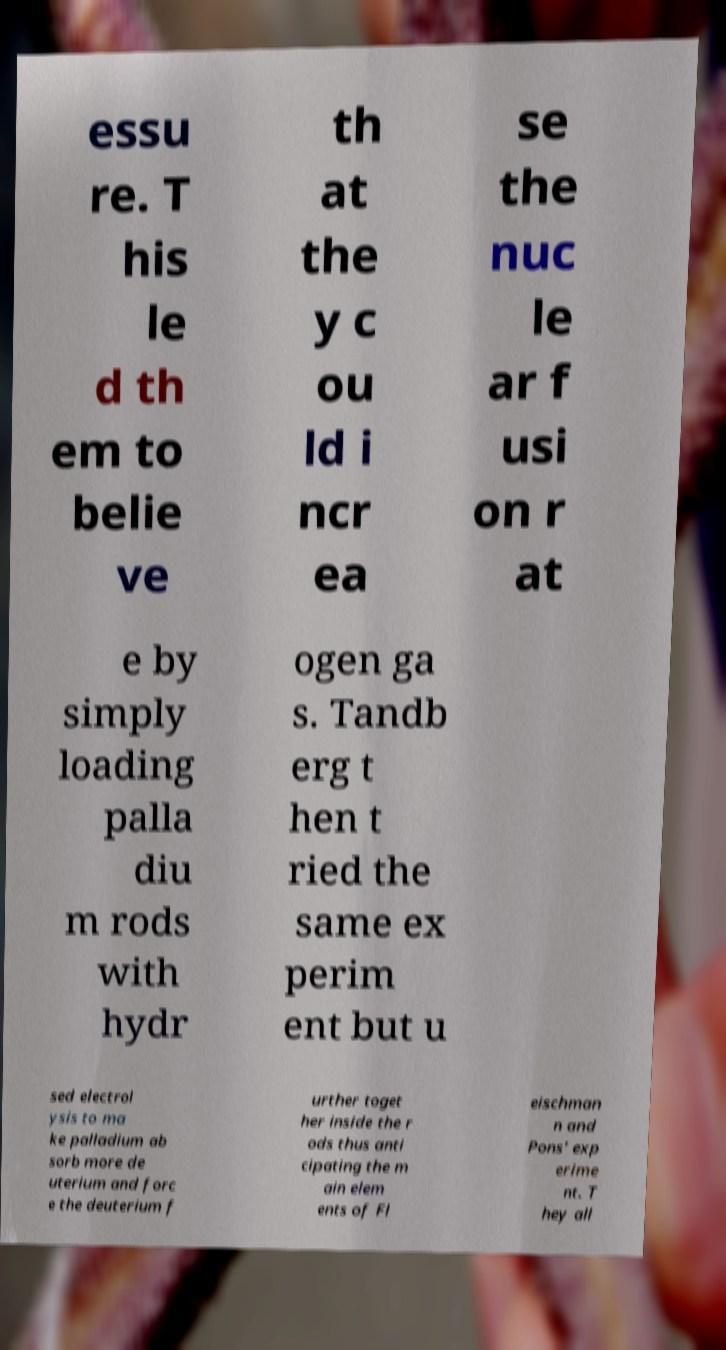Could you assist in decoding the text presented in this image and type it out clearly? essu re. T his le d th em to belie ve th at the y c ou ld i ncr ea se the nuc le ar f usi on r at e by simply loading palla diu m rods with hydr ogen ga s. Tandb erg t hen t ried the same ex perim ent but u sed electrol ysis to ma ke palladium ab sorb more de uterium and forc e the deuterium f urther toget her inside the r ods thus anti cipating the m ain elem ents of Fl eischman n and Pons' exp erime nt. T hey all 